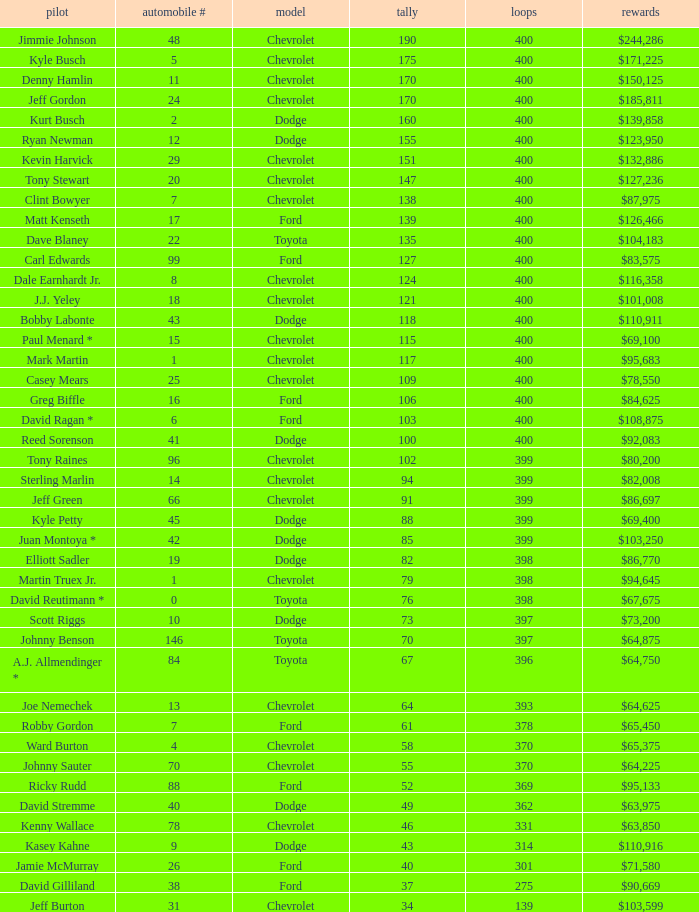What is the make of car 31? Chevrolet. Write the full table. {'header': ['pilot', 'automobile #', 'model', 'tally', 'loops', 'rewards'], 'rows': [['Jimmie Johnson', '48', 'Chevrolet', '190', '400', '$244,286'], ['Kyle Busch', '5', 'Chevrolet', '175', '400', '$171,225'], ['Denny Hamlin', '11', 'Chevrolet', '170', '400', '$150,125'], ['Jeff Gordon', '24', 'Chevrolet', '170', '400', '$185,811'], ['Kurt Busch', '2', 'Dodge', '160', '400', '$139,858'], ['Ryan Newman', '12', 'Dodge', '155', '400', '$123,950'], ['Kevin Harvick', '29', 'Chevrolet', '151', '400', '$132,886'], ['Tony Stewart', '20', 'Chevrolet', '147', '400', '$127,236'], ['Clint Bowyer', '7', 'Chevrolet', '138', '400', '$87,975'], ['Matt Kenseth', '17', 'Ford', '139', '400', '$126,466'], ['Dave Blaney', '22', 'Toyota', '135', '400', '$104,183'], ['Carl Edwards', '99', 'Ford', '127', '400', '$83,575'], ['Dale Earnhardt Jr.', '8', 'Chevrolet', '124', '400', '$116,358'], ['J.J. Yeley', '18', 'Chevrolet', '121', '400', '$101,008'], ['Bobby Labonte', '43', 'Dodge', '118', '400', '$110,911'], ['Paul Menard *', '15', 'Chevrolet', '115', '400', '$69,100'], ['Mark Martin', '1', 'Chevrolet', '117', '400', '$95,683'], ['Casey Mears', '25', 'Chevrolet', '109', '400', '$78,550'], ['Greg Biffle', '16', 'Ford', '106', '400', '$84,625'], ['David Ragan *', '6', 'Ford', '103', '400', '$108,875'], ['Reed Sorenson', '41', 'Dodge', '100', '400', '$92,083'], ['Tony Raines', '96', 'Chevrolet', '102', '399', '$80,200'], ['Sterling Marlin', '14', 'Chevrolet', '94', '399', '$82,008'], ['Jeff Green', '66', 'Chevrolet', '91', '399', '$86,697'], ['Kyle Petty', '45', 'Dodge', '88', '399', '$69,400'], ['Juan Montoya *', '42', 'Dodge', '85', '399', '$103,250'], ['Elliott Sadler', '19', 'Dodge', '82', '398', '$86,770'], ['Martin Truex Jr.', '1', 'Chevrolet', '79', '398', '$94,645'], ['David Reutimann *', '0', 'Toyota', '76', '398', '$67,675'], ['Scott Riggs', '10', 'Dodge', '73', '397', '$73,200'], ['Johnny Benson', '146', 'Toyota', '70', '397', '$64,875'], ['A.J. Allmendinger *', '84', 'Toyota', '67', '396', '$64,750'], ['Joe Nemechek', '13', 'Chevrolet', '64', '393', '$64,625'], ['Robby Gordon', '7', 'Ford', '61', '378', '$65,450'], ['Ward Burton', '4', 'Chevrolet', '58', '370', '$65,375'], ['Johnny Sauter', '70', 'Chevrolet', '55', '370', '$64,225'], ['Ricky Rudd', '88', 'Ford', '52', '369', '$95,133'], ['David Stremme', '40', 'Dodge', '49', '362', '$63,975'], ['Kenny Wallace', '78', 'Chevrolet', '46', '331', '$63,850'], ['Kasey Kahne', '9', 'Dodge', '43', '314', '$110,916'], ['Jamie McMurray', '26', 'Ford', '40', '301', '$71,580'], ['David Gilliland', '38', 'Ford', '37', '275', '$90,669'], ['Jeff Burton', '31', 'Chevrolet', '34', '139', '$103,599']]} 